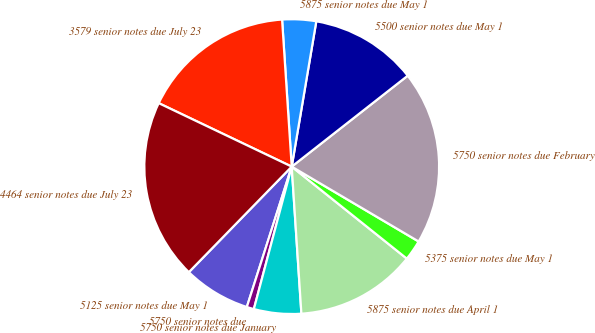Convert chart. <chart><loc_0><loc_0><loc_500><loc_500><pie_chart><fcel>5125 senior notes due May 1<fcel>5750 senior notes due<fcel>5750 senior notes due January<fcel>5875 senior notes due April 1<fcel>5375 senior notes due May 1<fcel>5750 senior notes due February<fcel>5500 senior notes due May 1<fcel>5875 senior notes due May 1<fcel>3579 senior notes due July 23<fcel>4464 senior notes due July 23<nl><fcel>7.37%<fcel>0.79%<fcel>5.18%<fcel>13.22%<fcel>2.25%<fcel>19.06%<fcel>11.75%<fcel>3.71%<fcel>16.87%<fcel>19.79%<nl></chart> 